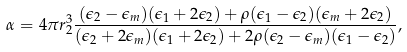Convert formula to latex. <formula><loc_0><loc_0><loc_500><loc_500>\alpha = 4 \pi r _ { 2 } ^ { 3 } \frac { ( \epsilon _ { 2 } - \epsilon _ { m } ) ( \epsilon _ { 1 } + 2 \epsilon _ { 2 } ) + \rho ( \epsilon _ { 1 } - \epsilon _ { 2 } ) ( \epsilon _ { m } + 2 \epsilon _ { 2 } ) } { ( \epsilon _ { 2 } + 2 \epsilon _ { m } ) ( \epsilon _ { 1 } + 2 \epsilon _ { 2 } ) + 2 \rho ( \epsilon _ { 2 } - \epsilon _ { m } ) ( \epsilon _ { 1 } - \epsilon _ { 2 } ) } ,</formula> 